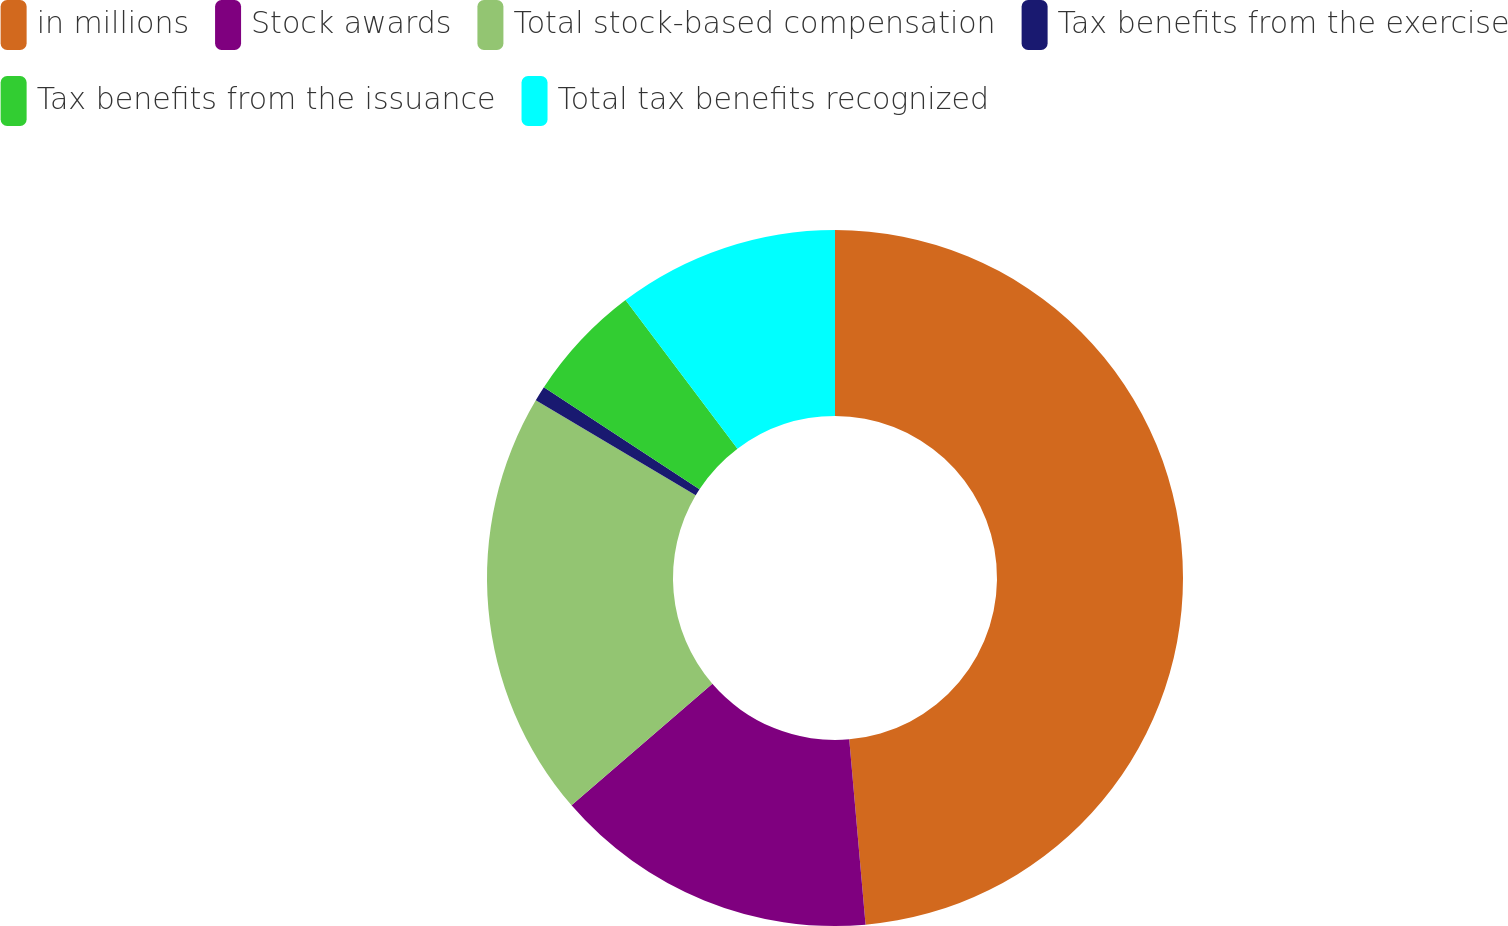<chart> <loc_0><loc_0><loc_500><loc_500><pie_chart><fcel>in millions<fcel>Stock awards<fcel>Total stock-based compensation<fcel>Tax benefits from the exercise<fcel>Tax benefits from the issuance<fcel>Total tax benefits recognized<nl><fcel>48.6%<fcel>15.07%<fcel>19.86%<fcel>0.7%<fcel>5.49%<fcel>10.28%<nl></chart> 